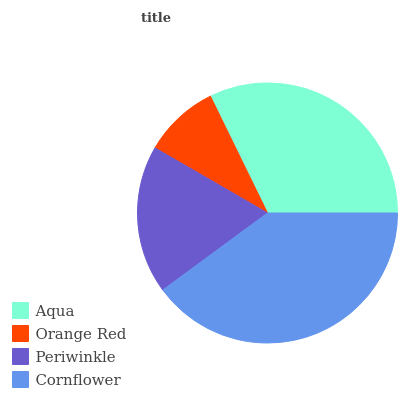Is Orange Red the minimum?
Answer yes or no. Yes. Is Cornflower the maximum?
Answer yes or no. Yes. Is Periwinkle the minimum?
Answer yes or no. No. Is Periwinkle the maximum?
Answer yes or no. No. Is Periwinkle greater than Orange Red?
Answer yes or no. Yes. Is Orange Red less than Periwinkle?
Answer yes or no. Yes. Is Orange Red greater than Periwinkle?
Answer yes or no. No. Is Periwinkle less than Orange Red?
Answer yes or no. No. Is Aqua the high median?
Answer yes or no. Yes. Is Periwinkle the low median?
Answer yes or no. Yes. Is Cornflower the high median?
Answer yes or no. No. Is Aqua the low median?
Answer yes or no. No. 